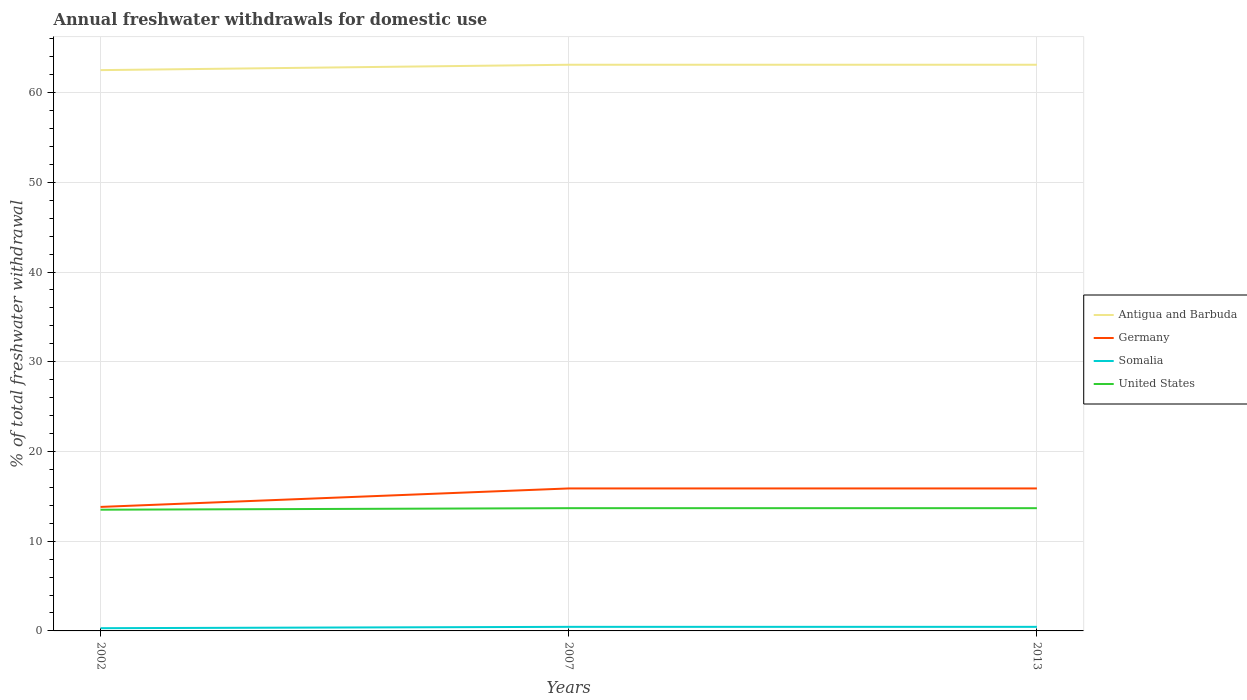How many different coloured lines are there?
Provide a short and direct response. 4. Across all years, what is the maximum total annual withdrawals from freshwater in United States?
Make the answer very short. 13.51. What is the total total annual withdrawals from freshwater in Germany in the graph?
Keep it short and to the point. -2.06. What is the difference between the highest and the second highest total annual withdrawals from freshwater in Antigua and Barbuda?
Your answer should be compact. 0.6. What is the difference between the highest and the lowest total annual withdrawals from freshwater in Somalia?
Offer a terse response. 2. How many lines are there?
Ensure brevity in your answer.  4. What is the difference between two consecutive major ticks on the Y-axis?
Ensure brevity in your answer.  10. Are the values on the major ticks of Y-axis written in scientific E-notation?
Make the answer very short. No. Does the graph contain any zero values?
Give a very brief answer. No. Does the graph contain grids?
Offer a terse response. Yes. Where does the legend appear in the graph?
Your response must be concise. Center right. How many legend labels are there?
Your answer should be very brief. 4. What is the title of the graph?
Give a very brief answer. Annual freshwater withdrawals for domestic use. What is the label or title of the X-axis?
Your response must be concise. Years. What is the label or title of the Y-axis?
Keep it short and to the point. % of total freshwater withdrawal. What is the % of total freshwater withdrawal in Antigua and Barbuda in 2002?
Offer a very short reply. 62.5. What is the % of total freshwater withdrawal in Germany in 2002?
Provide a short and direct response. 13.82. What is the % of total freshwater withdrawal of Somalia in 2002?
Make the answer very short. 0.3. What is the % of total freshwater withdrawal of United States in 2002?
Your answer should be compact. 13.51. What is the % of total freshwater withdrawal in Antigua and Barbuda in 2007?
Your answer should be compact. 63.1. What is the % of total freshwater withdrawal of Germany in 2007?
Provide a succinct answer. 15.88. What is the % of total freshwater withdrawal in Somalia in 2007?
Ensure brevity in your answer.  0.45. What is the % of total freshwater withdrawal of United States in 2007?
Your answer should be compact. 13.68. What is the % of total freshwater withdrawal of Antigua and Barbuda in 2013?
Your answer should be compact. 63.1. What is the % of total freshwater withdrawal of Germany in 2013?
Offer a very short reply. 15.88. What is the % of total freshwater withdrawal in Somalia in 2013?
Make the answer very short. 0.45. What is the % of total freshwater withdrawal of United States in 2013?
Your response must be concise. 13.68. Across all years, what is the maximum % of total freshwater withdrawal in Antigua and Barbuda?
Your response must be concise. 63.1. Across all years, what is the maximum % of total freshwater withdrawal of Germany?
Your answer should be very brief. 15.88. Across all years, what is the maximum % of total freshwater withdrawal in Somalia?
Offer a very short reply. 0.45. Across all years, what is the maximum % of total freshwater withdrawal in United States?
Your answer should be compact. 13.68. Across all years, what is the minimum % of total freshwater withdrawal in Antigua and Barbuda?
Your answer should be compact. 62.5. Across all years, what is the minimum % of total freshwater withdrawal of Germany?
Make the answer very short. 13.82. Across all years, what is the minimum % of total freshwater withdrawal of Somalia?
Give a very brief answer. 0.3. Across all years, what is the minimum % of total freshwater withdrawal in United States?
Make the answer very short. 13.51. What is the total % of total freshwater withdrawal of Antigua and Barbuda in the graph?
Make the answer very short. 188.7. What is the total % of total freshwater withdrawal of Germany in the graph?
Provide a short and direct response. 45.58. What is the total % of total freshwater withdrawal of Somalia in the graph?
Give a very brief answer. 1.21. What is the total % of total freshwater withdrawal of United States in the graph?
Offer a terse response. 40.87. What is the difference between the % of total freshwater withdrawal of Germany in 2002 and that in 2007?
Make the answer very short. -2.06. What is the difference between the % of total freshwater withdrawal in Somalia in 2002 and that in 2007?
Offer a very short reply. -0.15. What is the difference between the % of total freshwater withdrawal of United States in 2002 and that in 2007?
Your answer should be very brief. -0.17. What is the difference between the % of total freshwater withdrawal of Germany in 2002 and that in 2013?
Give a very brief answer. -2.06. What is the difference between the % of total freshwater withdrawal of Somalia in 2002 and that in 2013?
Ensure brevity in your answer.  -0.15. What is the difference between the % of total freshwater withdrawal in United States in 2002 and that in 2013?
Make the answer very short. -0.17. What is the difference between the % of total freshwater withdrawal of Antigua and Barbuda in 2007 and that in 2013?
Provide a short and direct response. 0. What is the difference between the % of total freshwater withdrawal of Germany in 2007 and that in 2013?
Your answer should be very brief. 0. What is the difference between the % of total freshwater withdrawal of Somalia in 2007 and that in 2013?
Ensure brevity in your answer.  0. What is the difference between the % of total freshwater withdrawal of Antigua and Barbuda in 2002 and the % of total freshwater withdrawal of Germany in 2007?
Your answer should be compact. 46.62. What is the difference between the % of total freshwater withdrawal in Antigua and Barbuda in 2002 and the % of total freshwater withdrawal in Somalia in 2007?
Offer a very short reply. 62.05. What is the difference between the % of total freshwater withdrawal of Antigua and Barbuda in 2002 and the % of total freshwater withdrawal of United States in 2007?
Offer a terse response. 48.82. What is the difference between the % of total freshwater withdrawal of Germany in 2002 and the % of total freshwater withdrawal of Somalia in 2007?
Keep it short and to the point. 13.37. What is the difference between the % of total freshwater withdrawal in Germany in 2002 and the % of total freshwater withdrawal in United States in 2007?
Ensure brevity in your answer.  0.14. What is the difference between the % of total freshwater withdrawal in Somalia in 2002 and the % of total freshwater withdrawal in United States in 2007?
Keep it short and to the point. -13.38. What is the difference between the % of total freshwater withdrawal of Antigua and Barbuda in 2002 and the % of total freshwater withdrawal of Germany in 2013?
Provide a succinct answer. 46.62. What is the difference between the % of total freshwater withdrawal of Antigua and Barbuda in 2002 and the % of total freshwater withdrawal of Somalia in 2013?
Offer a very short reply. 62.05. What is the difference between the % of total freshwater withdrawal of Antigua and Barbuda in 2002 and the % of total freshwater withdrawal of United States in 2013?
Keep it short and to the point. 48.82. What is the difference between the % of total freshwater withdrawal of Germany in 2002 and the % of total freshwater withdrawal of Somalia in 2013?
Your answer should be compact. 13.37. What is the difference between the % of total freshwater withdrawal of Germany in 2002 and the % of total freshwater withdrawal of United States in 2013?
Your response must be concise. 0.14. What is the difference between the % of total freshwater withdrawal of Somalia in 2002 and the % of total freshwater withdrawal of United States in 2013?
Offer a terse response. -13.38. What is the difference between the % of total freshwater withdrawal in Antigua and Barbuda in 2007 and the % of total freshwater withdrawal in Germany in 2013?
Your answer should be very brief. 47.22. What is the difference between the % of total freshwater withdrawal of Antigua and Barbuda in 2007 and the % of total freshwater withdrawal of Somalia in 2013?
Your response must be concise. 62.65. What is the difference between the % of total freshwater withdrawal in Antigua and Barbuda in 2007 and the % of total freshwater withdrawal in United States in 2013?
Give a very brief answer. 49.42. What is the difference between the % of total freshwater withdrawal in Germany in 2007 and the % of total freshwater withdrawal in Somalia in 2013?
Offer a terse response. 15.43. What is the difference between the % of total freshwater withdrawal of Somalia in 2007 and the % of total freshwater withdrawal of United States in 2013?
Offer a very short reply. -13.23. What is the average % of total freshwater withdrawal of Antigua and Barbuda per year?
Provide a succinct answer. 62.9. What is the average % of total freshwater withdrawal in Germany per year?
Provide a succinct answer. 15.19. What is the average % of total freshwater withdrawal in Somalia per year?
Provide a short and direct response. 0.4. What is the average % of total freshwater withdrawal in United States per year?
Give a very brief answer. 13.62. In the year 2002, what is the difference between the % of total freshwater withdrawal in Antigua and Barbuda and % of total freshwater withdrawal in Germany?
Provide a succinct answer. 48.68. In the year 2002, what is the difference between the % of total freshwater withdrawal in Antigua and Barbuda and % of total freshwater withdrawal in Somalia?
Keep it short and to the point. 62.2. In the year 2002, what is the difference between the % of total freshwater withdrawal in Antigua and Barbuda and % of total freshwater withdrawal in United States?
Ensure brevity in your answer.  48.99. In the year 2002, what is the difference between the % of total freshwater withdrawal of Germany and % of total freshwater withdrawal of Somalia?
Your answer should be very brief. 13.52. In the year 2002, what is the difference between the % of total freshwater withdrawal in Germany and % of total freshwater withdrawal in United States?
Your answer should be very brief. 0.31. In the year 2002, what is the difference between the % of total freshwater withdrawal of Somalia and % of total freshwater withdrawal of United States?
Provide a succinct answer. -13.21. In the year 2007, what is the difference between the % of total freshwater withdrawal in Antigua and Barbuda and % of total freshwater withdrawal in Germany?
Your response must be concise. 47.22. In the year 2007, what is the difference between the % of total freshwater withdrawal of Antigua and Barbuda and % of total freshwater withdrawal of Somalia?
Your response must be concise. 62.65. In the year 2007, what is the difference between the % of total freshwater withdrawal in Antigua and Barbuda and % of total freshwater withdrawal in United States?
Your answer should be compact. 49.42. In the year 2007, what is the difference between the % of total freshwater withdrawal of Germany and % of total freshwater withdrawal of Somalia?
Keep it short and to the point. 15.43. In the year 2007, what is the difference between the % of total freshwater withdrawal of Somalia and % of total freshwater withdrawal of United States?
Your answer should be very brief. -13.23. In the year 2013, what is the difference between the % of total freshwater withdrawal of Antigua and Barbuda and % of total freshwater withdrawal of Germany?
Ensure brevity in your answer.  47.22. In the year 2013, what is the difference between the % of total freshwater withdrawal in Antigua and Barbuda and % of total freshwater withdrawal in Somalia?
Give a very brief answer. 62.65. In the year 2013, what is the difference between the % of total freshwater withdrawal in Antigua and Barbuda and % of total freshwater withdrawal in United States?
Keep it short and to the point. 49.42. In the year 2013, what is the difference between the % of total freshwater withdrawal in Germany and % of total freshwater withdrawal in Somalia?
Your answer should be very brief. 15.43. In the year 2013, what is the difference between the % of total freshwater withdrawal in Somalia and % of total freshwater withdrawal in United States?
Provide a succinct answer. -13.23. What is the ratio of the % of total freshwater withdrawal in Antigua and Barbuda in 2002 to that in 2007?
Keep it short and to the point. 0.99. What is the ratio of the % of total freshwater withdrawal of Germany in 2002 to that in 2007?
Offer a terse response. 0.87. What is the ratio of the % of total freshwater withdrawal of Somalia in 2002 to that in 2007?
Offer a terse response. 0.67. What is the ratio of the % of total freshwater withdrawal in United States in 2002 to that in 2007?
Offer a terse response. 0.99. What is the ratio of the % of total freshwater withdrawal in Antigua and Barbuda in 2002 to that in 2013?
Your answer should be compact. 0.99. What is the ratio of the % of total freshwater withdrawal in Germany in 2002 to that in 2013?
Provide a short and direct response. 0.87. What is the ratio of the % of total freshwater withdrawal in Somalia in 2002 to that in 2013?
Your response must be concise. 0.67. What is the ratio of the % of total freshwater withdrawal in United States in 2002 to that in 2013?
Keep it short and to the point. 0.99. What is the ratio of the % of total freshwater withdrawal of Antigua and Barbuda in 2007 to that in 2013?
Your answer should be compact. 1. What is the ratio of the % of total freshwater withdrawal of Germany in 2007 to that in 2013?
Provide a short and direct response. 1. What is the difference between the highest and the second highest % of total freshwater withdrawal of United States?
Keep it short and to the point. 0. What is the difference between the highest and the lowest % of total freshwater withdrawal of Antigua and Barbuda?
Ensure brevity in your answer.  0.6. What is the difference between the highest and the lowest % of total freshwater withdrawal in Germany?
Your response must be concise. 2.06. What is the difference between the highest and the lowest % of total freshwater withdrawal of Somalia?
Offer a very short reply. 0.15. What is the difference between the highest and the lowest % of total freshwater withdrawal in United States?
Offer a very short reply. 0.17. 